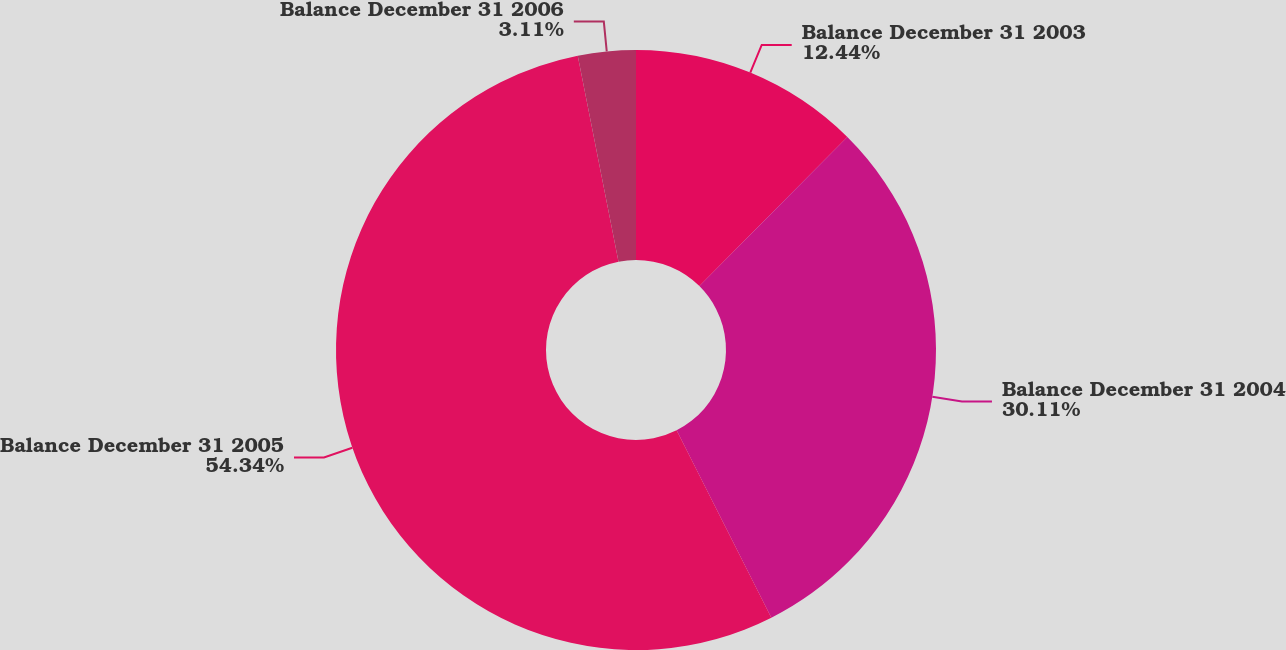Convert chart to OTSL. <chart><loc_0><loc_0><loc_500><loc_500><pie_chart><fcel>Balance December 31 2003<fcel>Balance December 31 2004<fcel>Balance December 31 2005<fcel>Balance December 31 2006<nl><fcel>12.44%<fcel>30.11%<fcel>54.34%<fcel>3.11%<nl></chart> 